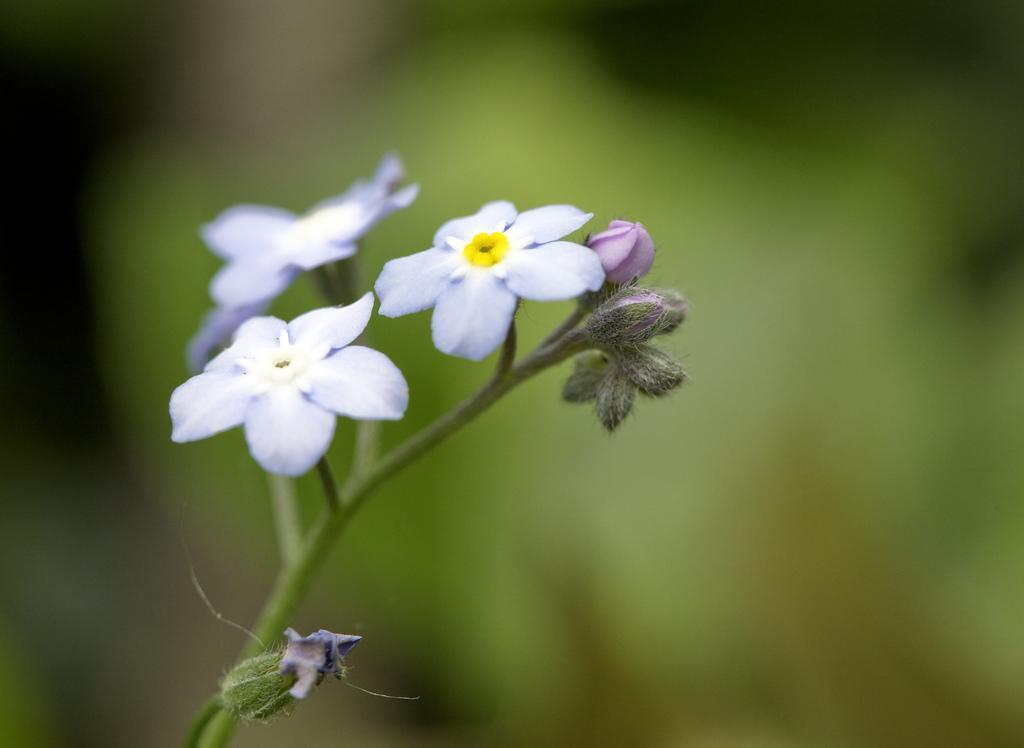Could you give a brief overview of what you see in this image? In this picture I can see there are few flowers attached to the stem of a plant. The backdrop is blurred. 